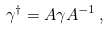Convert formula to latex. <formula><loc_0><loc_0><loc_500><loc_500>\gamma ^ { \dagger } = A \gamma A ^ { - 1 } \, ,</formula> 